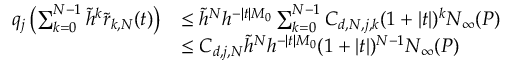Convert formula to latex. <formula><loc_0><loc_0><loc_500><loc_500>\begin{array} { r l } { q _ { j } \left ( \sum _ { k = 0 } ^ { N - 1 } \tilde { h } ^ { k } \tilde { r } _ { k , N } ( t ) \right ) } & { \leq \tilde { h } ^ { N } h ^ { - | t | M _ { 0 } } \sum _ { k = 0 } ^ { N - 1 } C _ { d , N , j , k } ( 1 + | t | ) ^ { k } N _ { \infty } ( P ) } \\ & { \leq C _ { d , j , N } \tilde { h } ^ { N } h ^ { - | t | M _ { 0 } } ( 1 + | t | ) ^ { N - 1 } N _ { \infty } ( P ) } \end{array}</formula> 